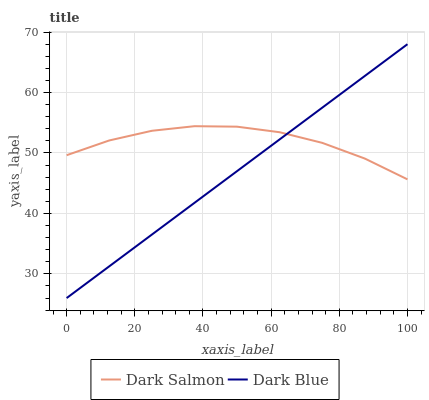Does Dark Blue have the minimum area under the curve?
Answer yes or no. Yes. Does Dark Salmon have the maximum area under the curve?
Answer yes or no. Yes. Does Dark Salmon have the minimum area under the curve?
Answer yes or no. No. Is Dark Blue the smoothest?
Answer yes or no. Yes. Is Dark Salmon the roughest?
Answer yes or no. Yes. Is Dark Salmon the smoothest?
Answer yes or no. No. Does Dark Blue have the lowest value?
Answer yes or no. Yes. Does Dark Salmon have the lowest value?
Answer yes or no. No. Does Dark Blue have the highest value?
Answer yes or no. Yes. Does Dark Salmon have the highest value?
Answer yes or no. No. Does Dark Blue intersect Dark Salmon?
Answer yes or no. Yes. Is Dark Blue less than Dark Salmon?
Answer yes or no. No. Is Dark Blue greater than Dark Salmon?
Answer yes or no. No. 